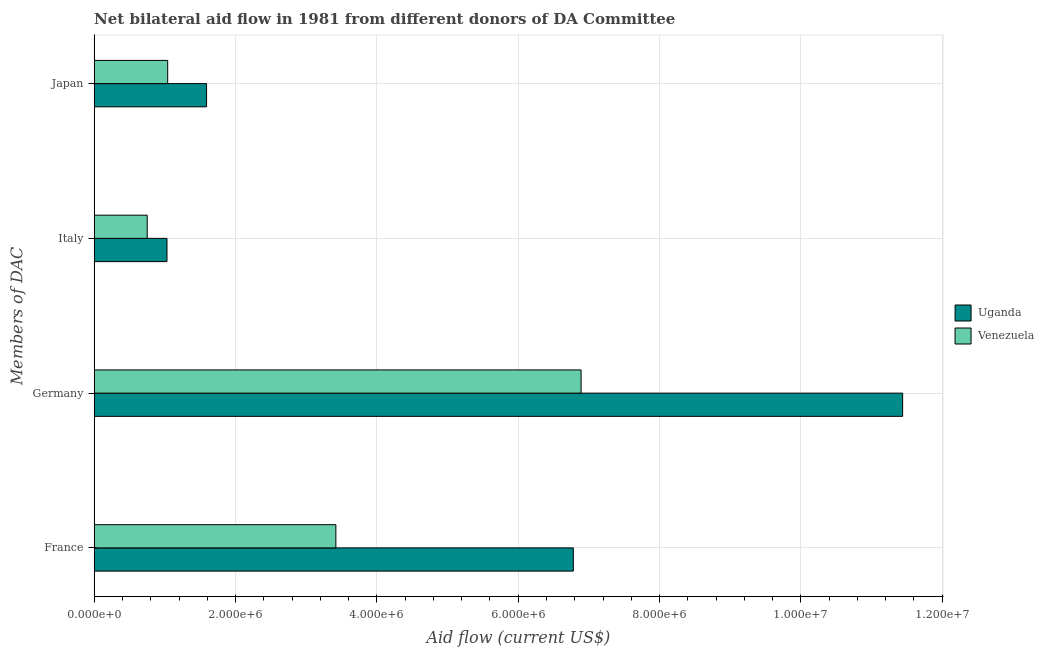How many different coloured bars are there?
Your answer should be compact. 2. How many bars are there on the 1st tick from the bottom?
Ensure brevity in your answer.  2. What is the amount of aid given by japan in Venezuela?
Provide a succinct answer. 1.04e+06. Across all countries, what is the maximum amount of aid given by japan?
Offer a terse response. 1.59e+06. Across all countries, what is the minimum amount of aid given by france?
Your answer should be very brief. 3.42e+06. In which country was the amount of aid given by italy maximum?
Keep it short and to the point. Uganda. In which country was the amount of aid given by france minimum?
Offer a terse response. Venezuela. What is the total amount of aid given by italy in the graph?
Make the answer very short. 1.78e+06. What is the difference between the amount of aid given by japan in Uganda and that in Venezuela?
Provide a succinct answer. 5.50e+05. What is the difference between the amount of aid given by france in Uganda and the amount of aid given by japan in Venezuela?
Make the answer very short. 5.74e+06. What is the average amount of aid given by germany per country?
Keep it short and to the point. 9.16e+06. What is the difference between the amount of aid given by japan and amount of aid given by italy in Venezuela?
Keep it short and to the point. 2.90e+05. In how many countries, is the amount of aid given by italy greater than 7600000 US$?
Make the answer very short. 0. What is the ratio of the amount of aid given by italy in Venezuela to that in Uganda?
Your answer should be very brief. 0.73. Is the amount of aid given by germany in Venezuela less than that in Uganda?
Your answer should be very brief. Yes. What is the difference between the highest and the second highest amount of aid given by germany?
Offer a very short reply. 4.55e+06. What is the difference between the highest and the lowest amount of aid given by italy?
Your response must be concise. 2.80e+05. Is the sum of the amount of aid given by france in Uganda and Venezuela greater than the maximum amount of aid given by japan across all countries?
Give a very brief answer. Yes. Is it the case that in every country, the sum of the amount of aid given by italy and amount of aid given by japan is greater than the sum of amount of aid given by germany and amount of aid given by france?
Your response must be concise. Yes. What does the 2nd bar from the top in Germany represents?
Provide a short and direct response. Uganda. What does the 1st bar from the bottom in Japan represents?
Ensure brevity in your answer.  Uganda. Is it the case that in every country, the sum of the amount of aid given by france and amount of aid given by germany is greater than the amount of aid given by italy?
Your answer should be very brief. Yes. How many countries are there in the graph?
Offer a very short reply. 2. Are the values on the major ticks of X-axis written in scientific E-notation?
Your answer should be compact. Yes. Does the graph contain any zero values?
Your answer should be very brief. No. Does the graph contain grids?
Ensure brevity in your answer.  Yes. Where does the legend appear in the graph?
Your response must be concise. Center right. What is the title of the graph?
Offer a very short reply. Net bilateral aid flow in 1981 from different donors of DA Committee. Does "Gabon" appear as one of the legend labels in the graph?
Provide a succinct answer. No. What is the label or title of the Y-axis?
Offer a very short reply. Members of DAC. What is the Aid flow (current US$) in Uganda in France?
Your response must be concise. 6.78e+06. What is the Aid flow (current US$) of Venezuela in France?
Offer a terse response. 3.42e+06. What is the Aid flow (current US$) of Uganda in Germany?
Ensure brevity in your answer.  1.14e+07. What is the Aid flow (current US$) in Venezuela in Germany?
Your answer should be compact. 6.89e+06. What is the Aid flow (current US$) of Uganda in Italy?
Your response must be concise. 1.03e+06. What is the Aid flow (current US$) of Venezuela in Italy?
Give a very brief answer. 7.50e+05. What is the Aid flow (current US$) of Uganda in Japan?
Provide a short and direct response. 1.59e+06. What is the Aid flow (current US$) in Venezuela in Japan?
Your response must be concise. 1.04e+06. Across all Members of DAC, what is the maximum Aid flow (current US$) in Uganda?
Offer a terse response. 1.14e+07. Across all Members of DAC, what is the maximum Aid flow (current US$) in Venezuela?
Provide a short and direct response. 6.89e+06. Across all Members of DAC, what is the minimum Aid flow (current US$) in Uganda?
Provide a short and direct response. 1.03e+06. Across all Members of DAC, what is the minimum Aid flow (current US$) of Venezuela?
Your answer should be compact. 7.50e+05. What is the total Aid flow (current US$) of Uganda in the graph?
Your answer should be very brief. 2.08e+07. What is the total Aid flow (current US$) in Venezuela in the graph?
Your answer should be compact. 1.21e+07. What is the difference between the Aid flow (current US$) of Uganda in France and that in Germany?
Provide a short and direct response. -4.66e+06. What is the difference between the Aid flow (current US$) in Venezuela in France and that in Germany?
Offer a terse response. -3.47e+06. What is the difference between the Aid flow (current US$) in Uganda in France and that in Italy?
Your answer should be very brief. 5.75e+06. What is the difference between the Aid flow (current US$) of Venezuela in France and that in Italy?
Give a very brief answer. 2.67e+06. What is the difference between the Aid flow (current US$) in Uganda in France and that in Japan?
Give a very brief answer. 5.19e+06. What is the difference between the Aid flow (current US$) in Venezuela in France and that in Japan?
Give a very brief answer. 2.38e+06. What is the difference between the Aid flow (current US$) of Uganda in Germany and that in Italy?
Keep it short and to the point. 1.04e+07. What is the difference between the Aid flow (current US$) in Venezuela in Germany and that in Italy?
Your answer should be very brief. 6.14e+06. What is the difference between the Aid flow (current US$) in Uganda in Germany and that in Japan?
Offer a very short reply. 9.85e+06. What is the difference between the Aid flow (current US$) in Venezuela in Germany and that in Japan?
Make the answer very short. 5.85e+06. What is the difference between the Aid flow (current US$) of Uganda in Italy and that in Japan?
Provide a short and direct response. -5.60e+05. What is the difference between the Aid flow (current US$) of Venezuela in Italy and that in Japan?
Your response must be concise. -2.90e+05. What is the difference between the Aid flow (current US$) of Uganda in France and the Aid flow (current US$) of Venezuela in Germany?
Offer a terse response. -1.10e+05. What is the difference between the Aid flow (current US$) of Uganda in France and the Aid flow (current US$) of Venezuela in Italy?
Your response must be concise. 6.03e+06. What is the difference between the Aid flow (current US$) of Uganda in France and the Aid flow (current US$) of Venezuela in Japan?
Keep it short and to the point. 5.74e+06. What is the difference between the Aid flow (current US$) in Uganda in Germany and the Aid flow (current US$) in Venezuela in Italy?
Provide a short and direct response. 1.07e+07. What is the difference between the Aid flow (current US$) in Uganda in Germany and the Aid flow (current US$) in Venezuela in Japan?
Keep it short and to the point. 1.04e+07. What is the average Aid flow (current US$) in Uganda per Members of DAC?
Keep it short and to the point. 5.21e+06. What is the average Aid flow (current US$) in Venezuela per Members of DAC?
Offer a terse response. 3.02e+06. What is the difference between the Aid flow (current US$) in Uganda and Aid flow (current US$) in Venezuela in France?
Your response must be concise. 3.36e+06. What is the difference between the Aid flow (current US$) in Uganda and Aid flow (current US$) in Venezuela in Germany?
Your answer should be very brief. 4.55e+06. What is the ratio of the Aid flow (current US$) in Uganda in France to that in Germany?
Provide a short and direct response. 0.59. What is the ratio of the Aid flow (current US$) in Venezuela in France to that in Germany?
Offer a terse response. 0.5. What is the ratio of the Aid flow (current US$) of Uganda in France to that in Italy?
Offer a very short reply. 6.58. What is the ratio of the Aid flow (current US$) in Venezuela in France to that in Italy?
Provide a succinct answer. 4.56. What is the ratio of the Aid flow (current US$) of Uganda in France to that in Japan?
Give a very brief answer. 4.26. What is the ratio of the Aid flow (current US$) in Venezuela in France to that in Japan?
Your response must be concise. 3.29. What is the ratio of the Aid flow (current US$) of Uganda in Germany to that in Italy?
Keep it short and to the point. 11.11. What is the ratio of the Aid flow (current US$) in Venezuela in Germany to that in Italy?
Keep it short and to the point. 9.19. What is the ratio of the Aid flow (current US$) in Uganda in Germany to that in Japan?
Provide a short and direct response. 7.2. What is the ratio of the Aid flow (current US$) in Venezuela in Germany to that in Japan?
Your answer should be very brief. 6.62. What is the ratio of the Aid flow (current US$) in Uganda in Italy to that in Japan?
Give a very brief answer. 0.65. What is the ratio of the Aid flow (current US$) of Venezuela in Italy to that in Japan?
Your answer should be very brief. 0.72. What is the difference between the highest and the second highest Aid flow (current US$) in Uganda?
Your answer should be compact. 4.66e+06. What is the difference between the highest and the second highest Aid flow (current US$) of Venezuela?
Provide a short and direct response. 3.47e+06. What is the difference between the highest and the lowest Aid flow (current US$) of Uganda?
Make the answer very short. 1.04e+07. What is the difference between the highest and the lowest Aid flow (current US$) of Venezuela?
Keep it short and to the point. 6.14e+06. 